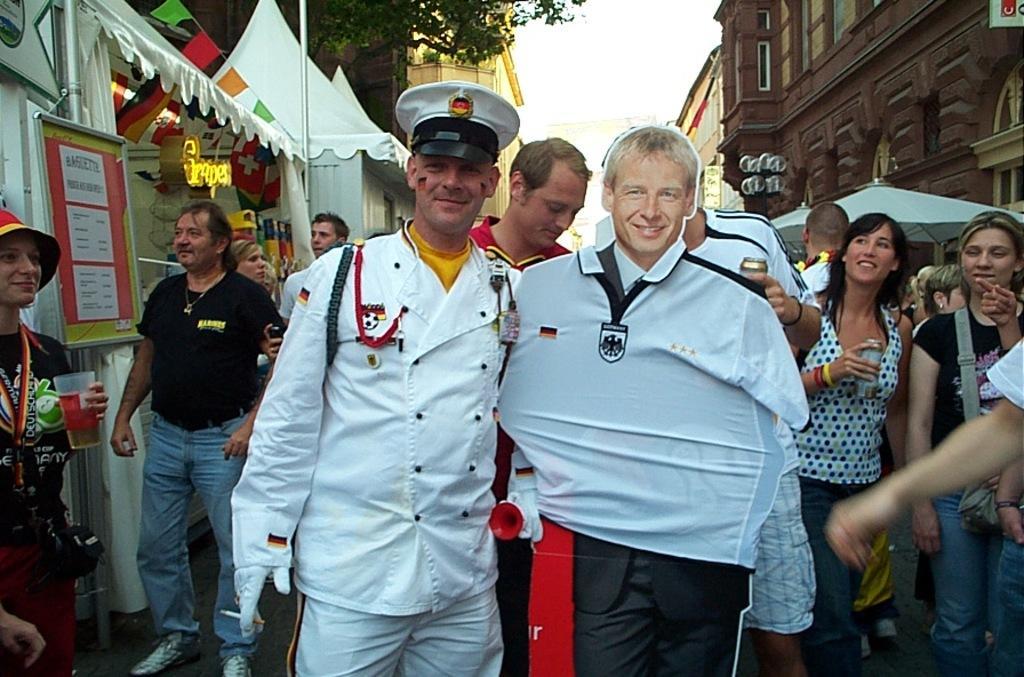How would you summarize this image in a sentence or two? In this image there are a few people standing on the road and few are holding an object in their hand. On the left side of the image there are stalls. In the background there are buildings. 